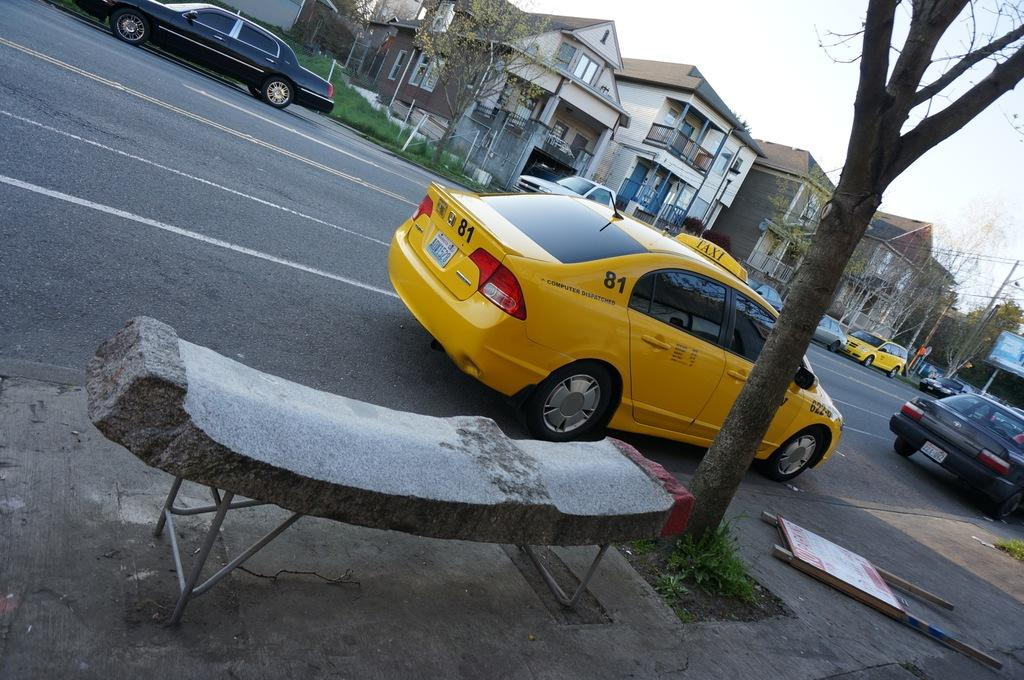<image>
Present a compact description of the photo's key features. a taxi that has the number \81 on it 